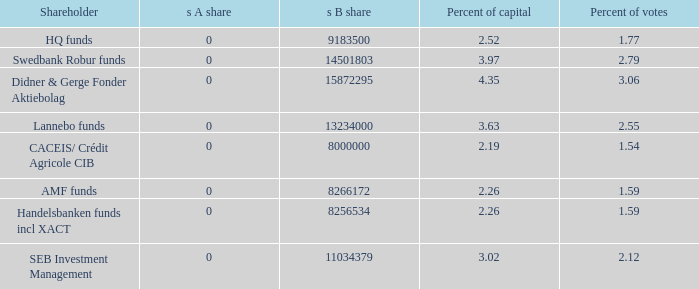What is the s B share for the shareholder that has 2.55 percent of votes?  13234000.0. 